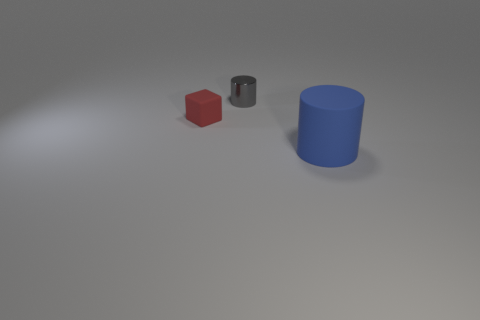What number of other large things are the same shape as the big blue thing?
Your answer should be very brief. 0. There is a rubber cube; does it have the same size as the cylinder that is behind the small red rubber cube?
Ensure brevity in your answer.  Yes. What shape is the matte thing that is to the left of the cylinder in front of the gray cylinder?
Your answer should be very brief. Cube. Are there fewer small gray metallic things in front of the blue cylinder than tiny shiny objects?
Your response must be concise. Yes. What number of gray metallic cylinders are the same size as the blue matte cylinder?
Your answer should be very brief. 0. What shape is the tiny object that is behind the cube?
Your response must be concise. Cylinder. Is the number of small gray metal cylinders less than the number of tiny green balls?
Offer a terse response. No. Is there any other thing of the same color as the rubber cylinder?
Make the answer very short. No. There is a matte object that is in front of the rubber cube; what is its size?
Provide a short and direct response. Large. Is the number of metal cylinders greater than the number of big red cylinders?
Keep it short and to the point. Yes. 